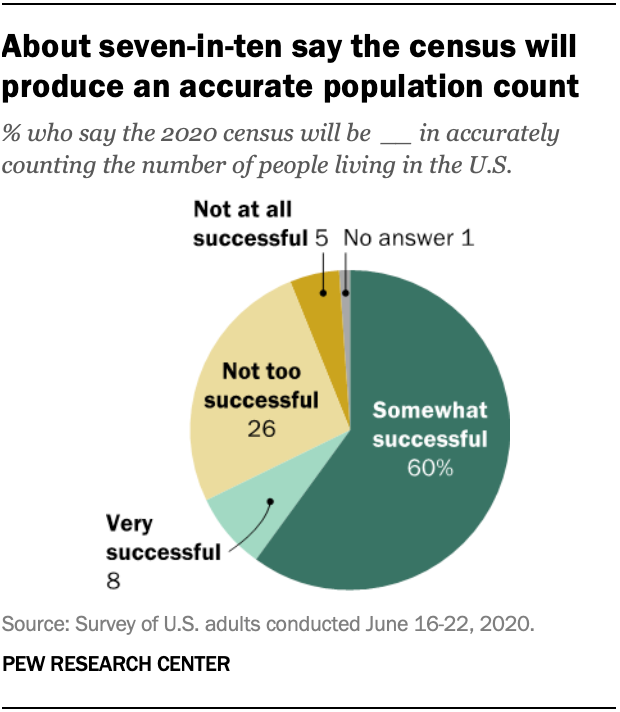Mention a couple of crucial points in this snapshot. The somewhat successful segment is estimated to have a percentage value of 60%. The ratio (A:B) of the largest segment and the second smallest segment is 0.500694444... 